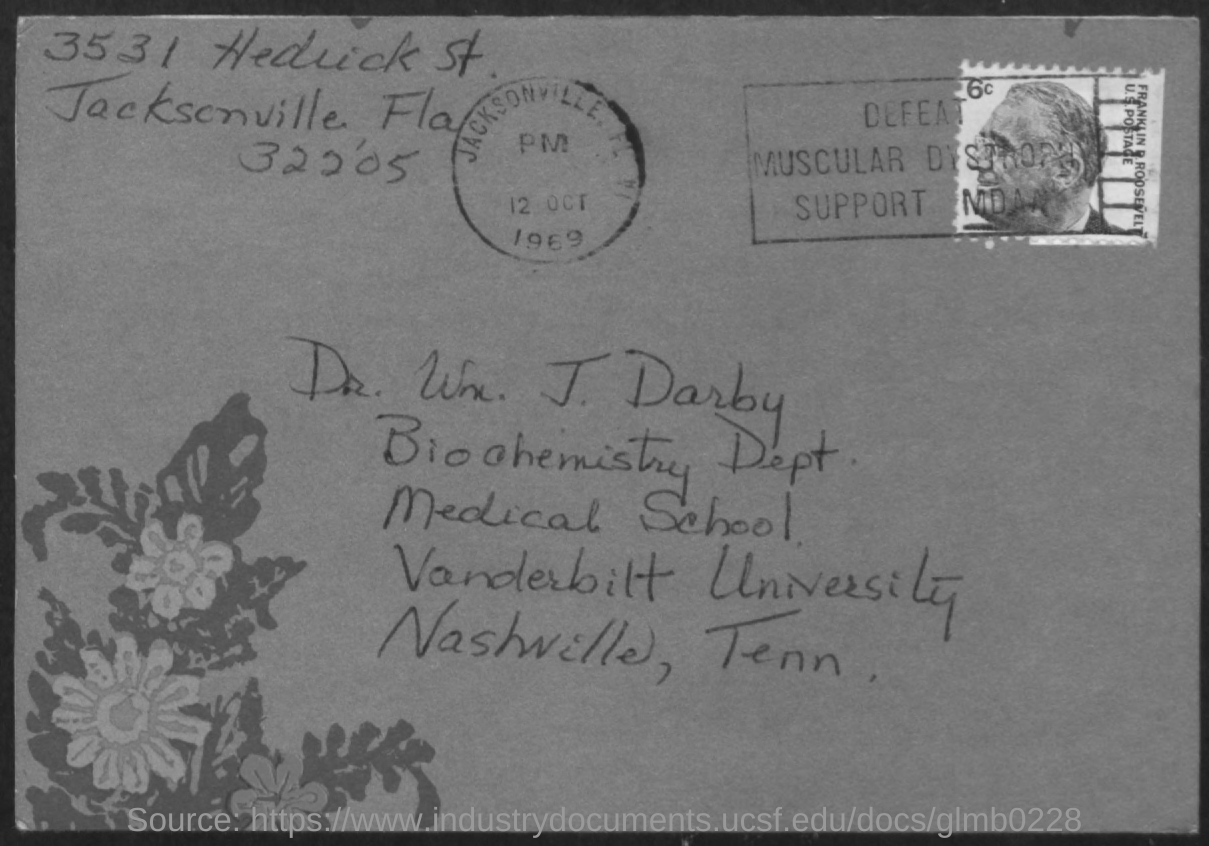Give some essential details in this illustration. The biochemistry department is mentioned. Vanderbilt University is mentioned. The letter is addressed to Dr. Wx. J. Darby. 